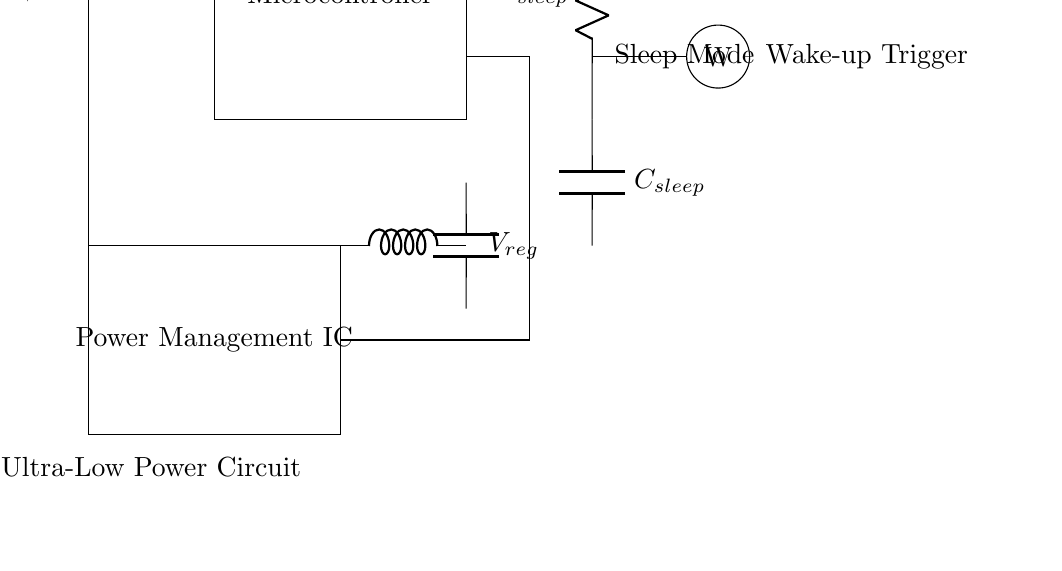What is the function of the switch in this circuit? The switch, labeled S1, controls the flow of current from the battery to the rest of the circuit. If the switch is open, there will be no current flow; when closed, it allows power to flow.
Answer: controls current flow What component is responsible for managing power in the circuit? The Power Management IC is specifically designed to regulate the power supplied to the microcontroller and other components, ensuring efficient operation.
Answer: Power Management IC What is the purpose of the resistor and capacitor in sleep mode? The resistor and capacitor, labeled as R_sleep and C_sleep, are used for creating a time delay in the sleep mode, allowing for a controlled shutdown process of the microcontroller to save power.
Answer: power saving How does the wake-up trigger function in this circuit? The wake-up trigger, denoted by W, is responsible for signaling the microcontroller to exit sleep mode. When activated, it allows the microcontroller to resume operations from a low power state.
Answer: exits sleep mode What is the output voltage label in this circuit? The output voltage after the voltage regulator is labeled as V_reg, which ensures that the power supplied to the components is maintained at a stable level during operation.
Answer: V_reg What type of circuit is this? This is an ultra-low power sleep mode circuit specifically designed for wearable devices to enhance battery longevity during inactive periods.
Answer: ultra-low power sleep mode Which component maintains the voltage while the device is in sleep mode? The voltage regulator maintains a steady voltage supply to the microcontroller and other components, ensuring they receive the required voltage even when in sleep mode.
Answer: Voltage regulator 